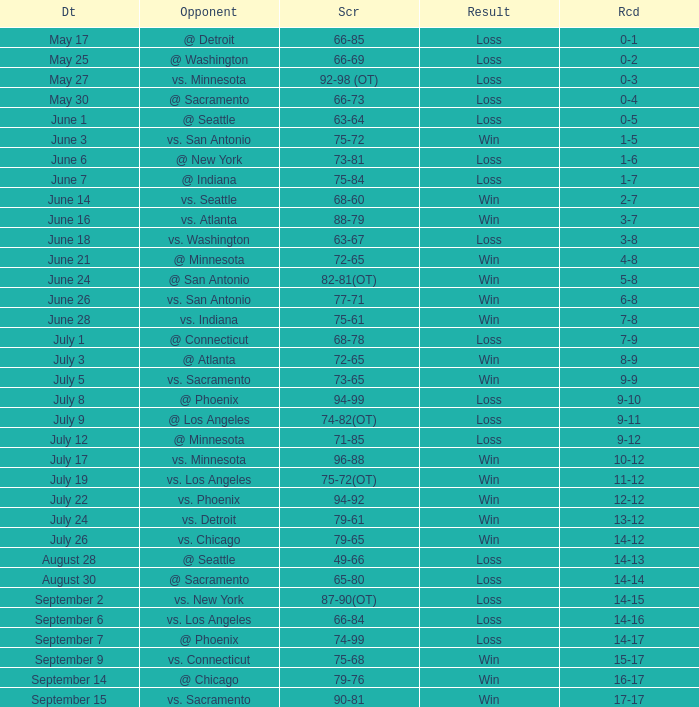Could you parse the entire table as a dict? {'header': ['Dt', 'Opponent', 'Scr', 'Result', 'Rcd'], 'rows': [['May 17', '@ Detroit', '66-85', 'Loss', '0-1'], ['May 25', '@ Washington', '66-69', 'Loss', '0-2'], ['May 27', 'vs. Minnesota', '92-98 (OT)', 'Loss', '0-3'], ['May 30', '@ Sacramento', '66-73', 'Loss', '0-4'], ['June 1', '@ Seattle', '63-64', 'Loss', '0-5'], ['June 3', 'vs. San Antonio', '75-72', 'Win', '1-5'], ['June 6', '@ New York', '73-81', 'Loss', '1-6'], ['June 7', '@ Indiana', '75-84', 'Loss', '1-7'], ['June 14', 'vs. Seattle', '68-60', 'Win', '2-7'], ['June 16', 'vs. Atlanta', '88-79', 'Win', '3-7'], ['June 18', 'vs. Washington', '63-67', 'Loss', '3-8'], ['June 21', '@ Minnesota', '72-65', 'Win', '4-8'], ['June 24', '@ San Antonio', '82-81(OT)', 'Win', '5-8'], ['June 26', 'vs. San Antonio', '77-71', 'Win', '6-8'], ['June 28', 'vs. Indiana', '75-61', 'Win', '7-8'], ['July 1', '@ Connecticut', '68-78', 'Loss', '7-9'], ['July 3', '@ Atlanta', '72-65', 'Win', '8-9'], ['July 5', 'vs. Sacramento', '73-65', 'Win', '9-9'], ['July 8', '@ Phoenix', '94-99', 'Loss', '9-10'], ['July 9', '@ Los Angeles', '74-82(OT)', 'Loss', '9-11'], ['July 12', '@ Minnesota', '71-85', 'Loss', '9-12'], ['July 17', 'vs. Minnesota', '96-88', 'Win', '10-12'], ['July 19', 'vs. Los Angeles', '75-72(OT)', 'Win', '11-12'], ['July 22', 'vs. Phoenix', '94-92', 'Win', '12-12'], ['July 24', 'vs. Detroit', '79-61', 'Win', '13-12'], ['July 26', 'vs. Chicago', '79-65', 'Win', '14-12'], ['August 28', '@ Seattle', '49-66', 'Loss', '14-13'], ['August 30', '@ Sacramento', '65-80', 'Loss', '14-14'], ['September 2', 'vs. New York', '87-90(OT)', 'Loss', '14-15'], ['September 6', 'vs. Los Angeles', '66-84', 'Loss', '14-16'], ['September 7', '@ Phoenix', '74-99', 'Loss', '14-17'], ['September 9', 'vs. Connecticut', '75-68', 'Win', '15-17'], ['September 14', '@ Chicago', '79-76', 'Win', '16-17'], ['September 15', 'vs. Sacramento', '90-81', 'Win', '17-17']]} What is the Record on July 12? 9-12. 